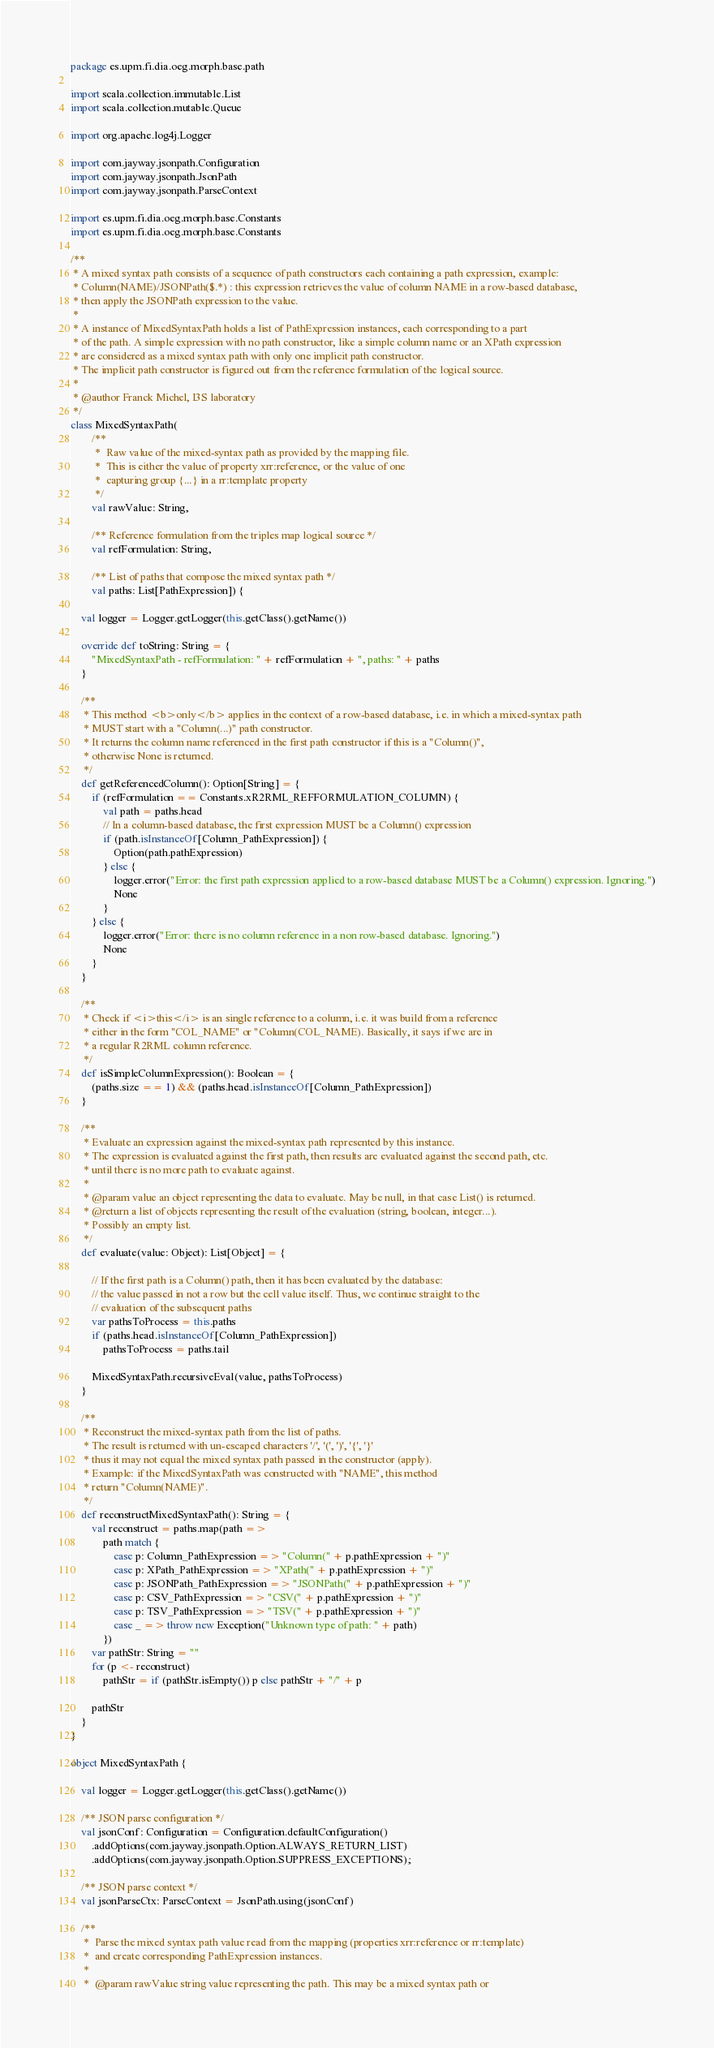<code> <loc_0><loc_0><loc_500><loc_500><_Scala_>package es.upm.fi.dia.oeg.morph.base.path

import scala.collection.immutable.List
import scala.collection.mutable.Queue

import org.apache.log4j.Logger

import com.jayway.jsonpath.Configuration
import com.jayway.jsonpath.JsonPath
import com.jayway.jsonpath.ParseContext

import es.upm.fi.dia.oeg.morph.base.Constants
import es.upm.fi.dia.oeg.morph.base.Constants

/**
 * A mixed syntax path consists of a sequence of path constructors each containing a path expression, example:
 * Column(NAME)/JSONPath($.*) : this expression retrieves the value of column NAME in a row-based database,
 * then apply the JSONPath expression to the value.
 *
 * A instance of MixedSyntaxPath holds a list of PathExpression instances, each corresponding to a part
 * of the path. A simple expression with no path constructor, like a simple column name or an XPath expression
 * are considered as a mixed syntax path with only one implicit path constructor.
 * The implicit path constructor is figured out from the reference formulation of the logical source.
 *
 * @author Franck Michel, I3S laboratory
 */
class MixedSyntaxPath(
        /**
         *  Raw value of the mixed-syntax path as provided by the mapping file.
         *  This is either the value of property xrr:reference, or the value of one
         *  capturing group {...} in a rr:template property
         */
        val rawValue: String,

        /** Reference formulation from the triples map logical source */
        val refFormulation: String,

        /** List of paths that compose the mixed syntax path */
        val paths: List[PathExpression]) {

    val logger = Logger.getLogger(this.getClass().getName())

    override def toString: String = {
        "MixedSyntaxPath - refFormulation: " + refFormulation + ", paths: " + paths
    }

    /**
     * This method <b>only</b> applies in the context of a row-based database, i.e. in which a mixed-syntax path
     * MUST start with a "Column(...)" path constructor.
     * It returns the column name referenced in the first path constructor if this is a "Column()",
     * otherwise None is returned.
     */
    def getReferencedColumn(): Option[String] = {
        if (refFormulation == Constants.xR2RML_REFFORMULATION_COLUMN) {
            val path = paths.head
            // In a column-based database, the first expression MUST be a Column() expression
            if (path.isInstanceOf[Column_PathExpression]) {
                Option(path.pathExpression)
            } else {
                logger.error("Error: the first path expression applied to a row-based database MUST be a Column() expression. Ignoring.")
                None
            }
        } else {
            logger.error("Error: there is no column reference in a non row-based database. Ignoring.")
            None
        }
    }

    /**
     * Check if <i>this</i> is an single reference to a column, i.e. it was build from a reference
     * either in the form "COL_NAME" or "Column(COL_NAME). Basically, it says if we are in
     * a regular R2RML column reference.
     */
    def isSimpleColumnExpression(): Boolean = {
        (paths.size == 1) && (paths.head.isInstanceOf[Column_PathExpression])
    }

    /**
     * Evaluate an expression against the mixed-syntax path represented by this instance.
     * The expression is evaluated against the first path, then results are evaluated against the second path, etc.
     * until there is no more path to evaluate against.
     *
     * @param value an object representing the data to evaluate. May be null, in that case List() is returned.
     * @return a list of objects representing the result of the evaluation (string, boolean, integer...).
     * Possibly an empty list.
     */
    def evaluate(value: Object): List[Object] = {

        // If the first path is a Column() path, then it has been evaluated by the database:
        // the value passed in not a row but the cell value itself. Thus, we continue straight to the
        // evaluation of the subsequent paths
        var pathsToProcess = this.paths
        if (paths.head.isInstanceOf[Column_PathExpression])
            pathsToProcess = paths.tail

        MixedSyntaxPath.recursiveEval(value, pathsToProcess)
    }

    /**
     * Reconstruct the mixed-syntax path from the list of paths.
     * The result is returned with un-escaped characters '/', '(', ')', '{', '}'
     * thus it may not equal the mixed syntax path passed in the constructor (apply).
     * Example: if the MixedSyntaxPath was constructed with "NAME", this method
     * return "Column(NAME)".
     */
    def reconstructMixedSyntaxPath(): String = {
        val reconstruct = paths.map(path =>
            path match {
                case p: Column_PathExpression => "Column(" + p.pathExpression + ")"
                case p: XPath_PathExpression => "XPath(" + p.pathExpression + ")"
                case p: JSONPath_PathExpression => "JSONPath(" + p.pathExpression + ")"
                case p: CSV_PathExpression => "CSV(" + p.pathExpression + ")"
                case p: TSV_PathExpression => "TSV(" + p.pathExpression + ")"
                case _ => throw new Exception("Unknown type of path: " + path)
            })
        var pathStr: String = ""
        for (p <- reconstruct)
            pathStr = if (pathStr.isEmpty()) p else pathStr + "/" + p

        pathStr
    }
}

object MixedSyntaxPath {

    val logger = Logger.getLogger(this.getClass().getName())

    /** JSON parse configuration */
    val jsonConf: Configuration = Configuration.defaultConfiguration()
        .addOptions(com.jayway.jsonpath.Option.ALWAYS_RETURN_LIST)
        .addOptions(com.jayway.jsonpath.Option.SUPPRESS_EXCEPTIONS);

    /** JSON parse context */
    val jsonParseCtx: ParseContext = JsonPath.using(jsonConf)

    /**
     *  Parse the mixed syntax path value read from the mapping (properties xrr:reference or rr:template)
     *  and create corresponding PathExpression instances.
     *
     *  @param rawValue string value representing the path. This may be a mixed syntax path or</code> 